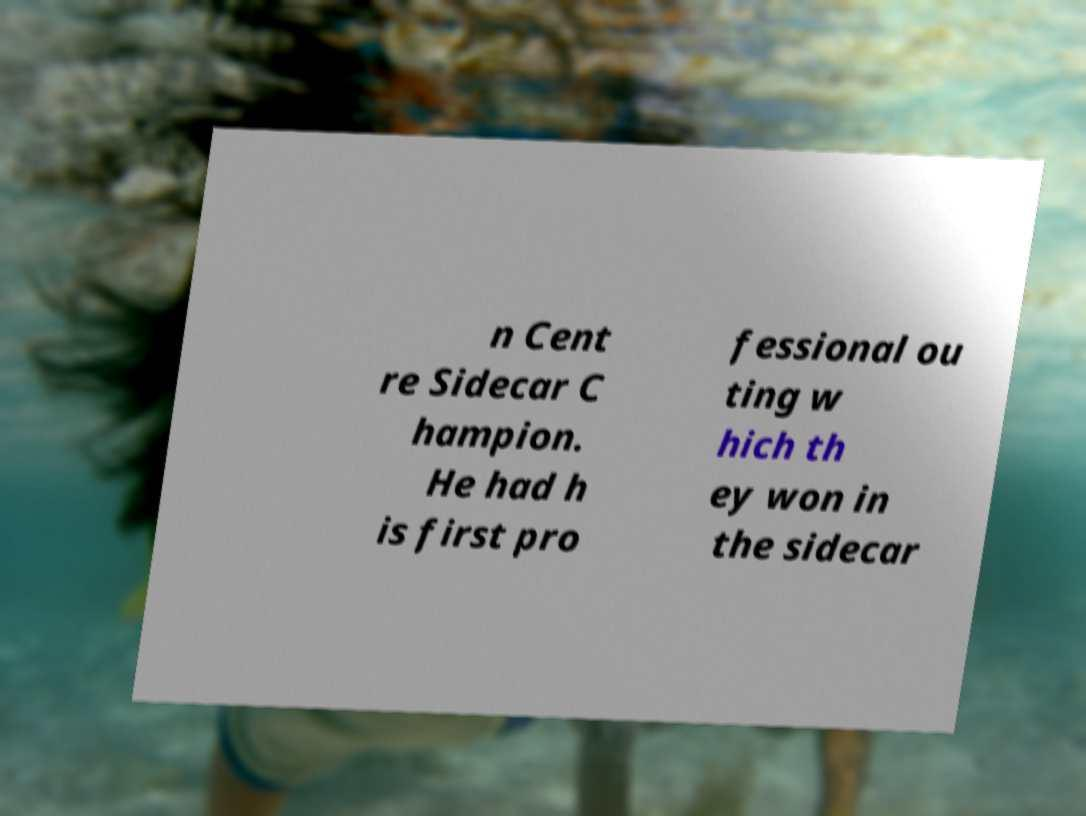Please read and relay the text visible in this image. What does it say? n Cent re Sidecar C hampion. He had h is first pro fessional ou ting w hich th ey won in the sidecar 